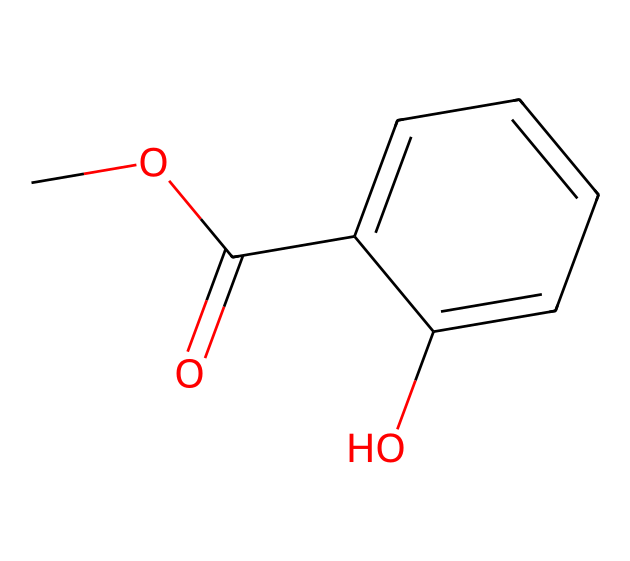What is the common name of this ester? The chemical structure corresponds to methyl salicylate, which is commonly known as wintergreen oil, derived from the wintergreen plant.
Answer: wintergreen oil How many carbon atoms are in this compound? Counting from the SMILES representation, there are 9 carbon atoms in total: 1 from the methoxy group and 8 from the aromatic and aliphatic portions of the ester.
Answer: 9 What functional group characterizes this molecule as an ester? The presence of the carbonyl group (C=O) adjacent to an ether link (-O-) indicates that this molecule is an ester.
Answer: carbonyl Are there any aromatic rings in methyl salicylate? Observing the structure reveals a six-membered ring with alternating double bonds, confirming the presence of an aromatic ring.
Answer: yes How many oxygen atoms are present in the molecule? The structure shows 2 oxygen atoms: one in the methoxy group and another in the carbonyl part of the ester.
Answer: 2 What is the effect of the hydroxyl (-OH) group on the properties of this ester? The -OH group in the structure introduces polar characteristics, which enhances hydrogen bonding and affects solubility and volatility.
Answer: polar Does methyl salicylate occur naturally or is it synthetic? Methyl salicylate is naturally found in plants such as wintergreen but can also be synthesized in laboratories.
Answer: naturally 